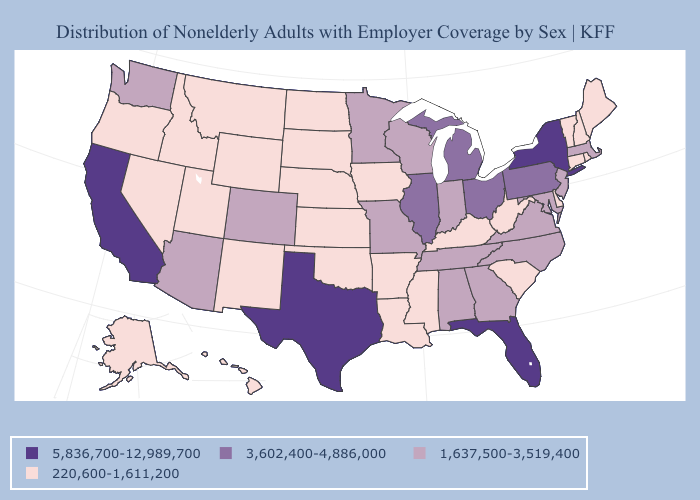What is the highest value in the MidWest ?
Answer briefly. 3,602,400-4,886,000. Which states hav the highest value in the South?
Give a very brief answer. Florida, Texas. What is the value of North Carolina?
Be succinct. 1,637,500-3,519,400. What is the value of Louisiana?
Give a very brief answer. 220,600-1,611,200. Among the states that border Arizona , does Utah have the lowest value?
Short answer required. Yes. Does Colorado have the same value as Virginia?
Keep it brief. Yes. Name the states that have a value in the range 3,602,400-4,886,000?
Quick response, please. Illinois, Michigan, Ohio, Pennsylvania. Which states have the lowest value in the USA?
Give a very brief answer. Alaska, Arkansas, Connecticut, Delaware, Hawaii, Idaho, Iowa, Kansas, Kentucky, Louisiana, Maine, Mississippi, Montana, Nebraska, Nevada, New Hampshire, New Mexico, North Dakota, Oklahoma, Oregon, Rhode Island, South Carolina, South Dakota, Utah, Vermont, West Virginia, Wyoming. Is the legend a continuous bar?
Concise answer only. No. Among the states that border Iowa , does Illinois have the highest value?
Be succinct. Yes. What is the value of Massachusetts?
Concise answer only. 1,637,500-3,519,400. Name the states that have a value in the range 220,600-1,611,200?
Be succinct. Alaska, Arkansas, Connecticut, Delaware, Hawaii, Idaho, Iowa, Kansas, Kentucky, Louisiana, Maine, Mississippi, Montana, Nebraska, Nevada, New Hampshire, New Mexico, North Dakota, Oklahoma, Oregon, Rhode Island, South Carolina, South Dakota, Utah, Vermont, West Virginia, Wyoming. What is the value of New Mexico?
Answer briefly. 220,600-1,611,200. Does Alabama have the same value as Kansas?
Concise answer only. No. Name the states that have a value in the range 220,600-1,611,200?
Keep it brief. Alaska, Arkansas, Connecticut, Delaware, Hawaii, Idaho, Iowa, Kansas, Kentucky, Louisiana, Maine, Mississippi, Montana, Nebraska, Nevada, New Hampshire, New Mexico, North Dakota, Oklahoma, Oregon, Rhode Island, South Carolina, South Dakota, Utah, Vermont, West Virginia, Wyoming. 